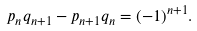Convert formula to latex. <formula><loc_0><loc_0><loc_500><loc_500>p _ { n } q _ { n + 1 } - p _ { n + 1 } q _ { n } = ( - 1 ) ^ { n + 1 } .</formula> 